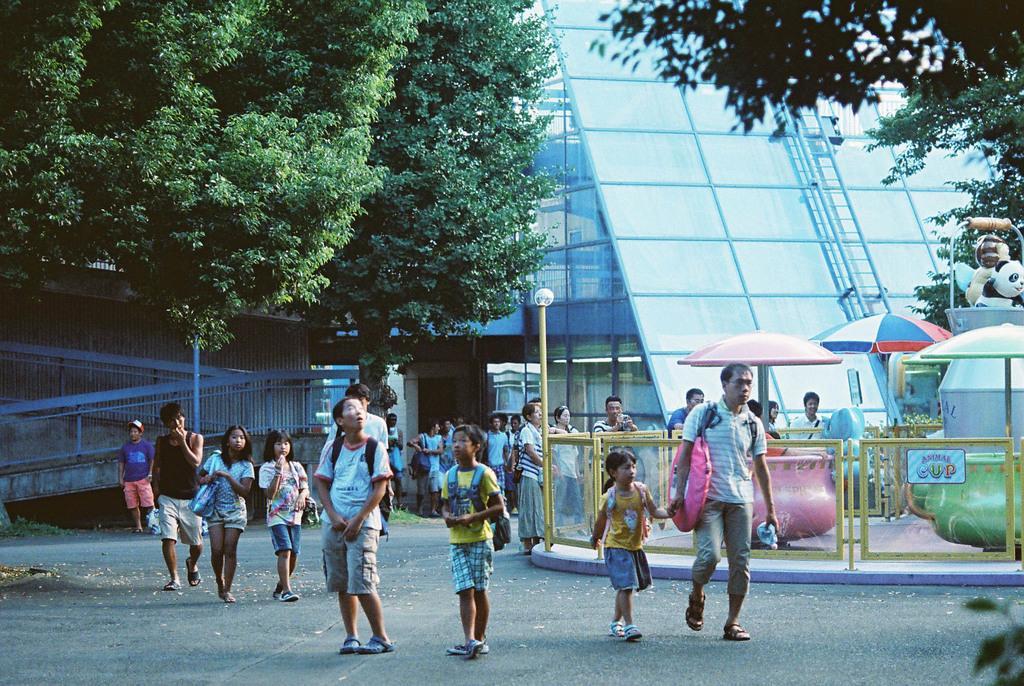Describe this image in one or two sentences. In this image I can see group of people standing and I can see few light poles, few umbrellas in multicolor. In the background I can see few trees in green color. I can also the glass building. 